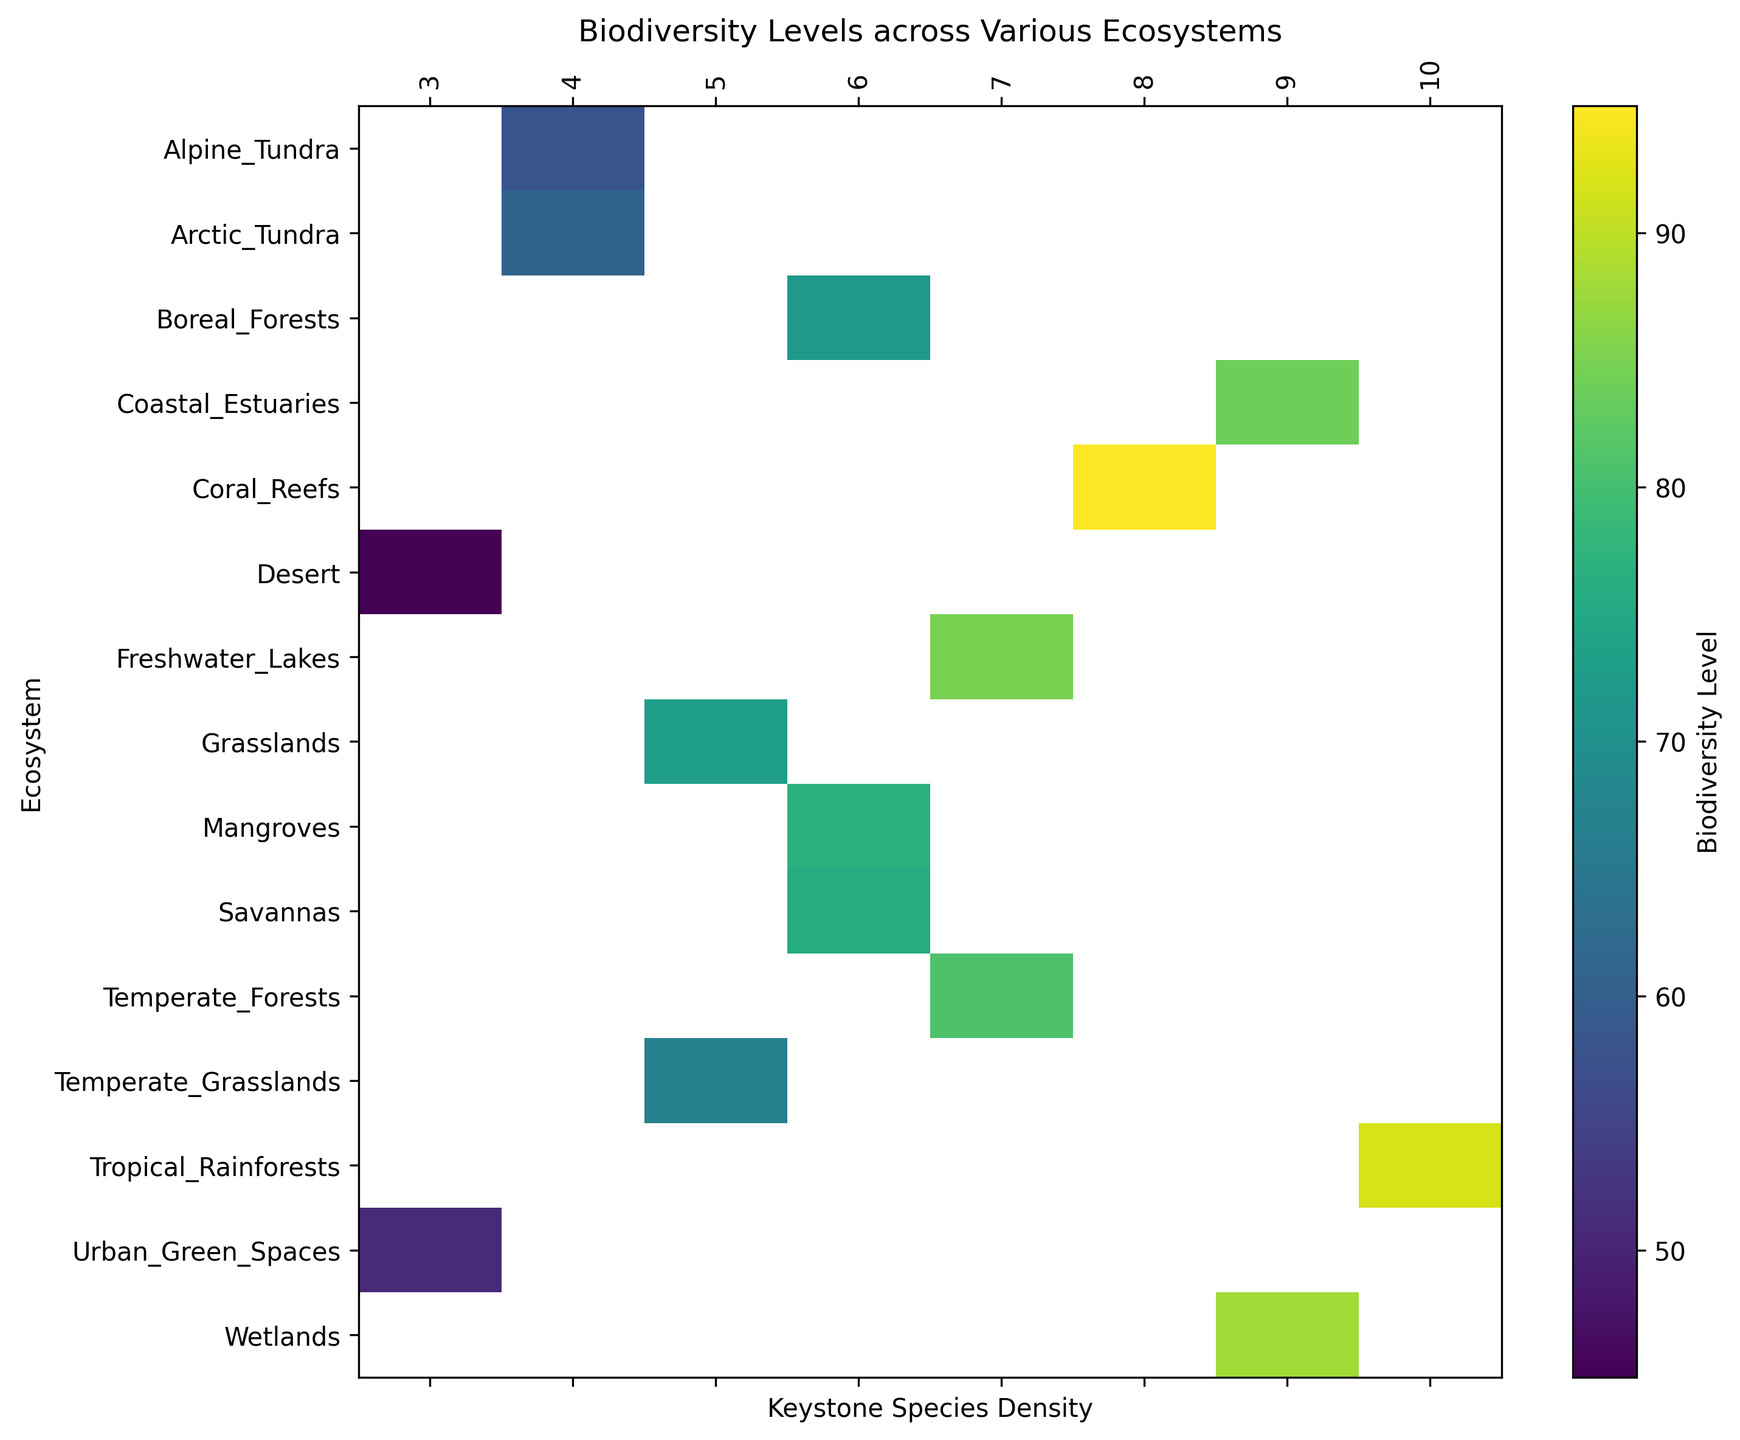What is the biodiversity level of Tropical Rainforests? Look at the cell corresponding to the Tropical Rainforests row and Keystone Species Density column. The color indicates the biodiversity level. According to the color bar, Tropical Rainforests have a biodiversity level of 92.
Answer: 92 Which ecosystem has the highest biodiversity level? Identify the cell with the darkest color, which represents the highest biodiversity level. The darkest cell corresponds to Coral Reefs.
Answer: Coral Reefs How does the biodiversity level of Mangroves compare to Alpine Tundra? Locate the cells for Mangroves and Alpine Tundra. Mangroves have a higher biodiversity level than Alpine Tundra according to the color intensity.
Answer: Mangroves are higher What is the biodiversity level range of ecosystems with a keystone species density of 7? Find all cells in the column for keystone species density of 7. The biodiversity levels range from 81 (Temperate Forests) to 85 (Freshwater Lakes).
Answer: 81 to 85 Which ecosystems have a keystone species density of 6, and what are their biodiversity levels? Identify the ecosystems in the column for keystone species density of 6: Savannas, Mangroves, and Boreal Forests. The biodiversity levels are 76, 77, and 72 respectively.
Answer: Savannas: 76, Mangroves: 77, Boreal Forests: 72 Is the biodiversity level of Wetlands closer to Coral Reefs or Freshwater Lakes? Determine the color intensity for Wetlands and compare it to Coral Reefs and Freshwater Lakes. Wetlands (88) have a similar color intensity to Freshwater Lakes (85), much closer than Coral Reefs (95).
Answer: Freshwater Lakes Rank the ecosystems with keystone species density of 4 from highest to lowest biodiversity level. Identify the rows for a density of 4: Alpine Tundra, Arctic Tundra. Compare their color intensity: Alpine Tundra has a higher biodiversity level than Arctic Tundra.
Answer: Alpine Tundra, Arctic Tundra Which ecosystem with a keystone species density of 3 has the lowest biodiversity level? Locate the cells for keystone species density of 3: Desert and Urban Green Spaces. Urban Green Spaces (51) have a higher biodiversity level than Desert (45).
Answer: Desert 